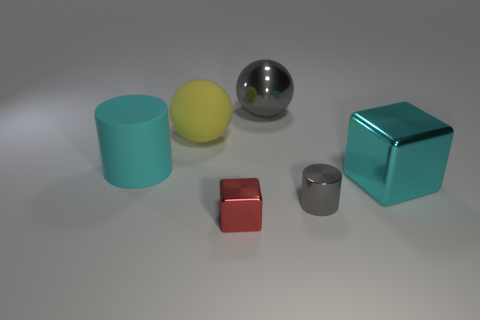How many large objects are there?
Provide a succinct answer. 4. Does the yellow ball have the same material as the tiny red thing?
Give a very brief answer. No. The large cyan thing in front of the cylinder behind the cyan object that is to the right of the large cyan cylinder is what shape?
Give a very brief answer. Cube. Does the ball on the left side of the tiny block have the same material as the big gray object that is behind the tiny red thing?
Offer a very short reply. No. What material is the small red thing?
Offer a very short reply. Metal. What number of other rubber objects have the same shape as the red object?
Ensure brevity in your answer.  0. There is a cylinder that is the same color as the metallic sphere; what is it made of?
Ensure brevity in your answer.  Metal. The ball right of the block to the left of the small thing that is behind the red thing is what color?
Provide a succinct answer. Gray. How many big things are either purple metallic objects or gray spheres?
Your answer should be compact. 1. Are there the same number of big yellow balls that are on the left side of the large rubber sphere and blue cylinders?
Make the answer very short. Yes. 